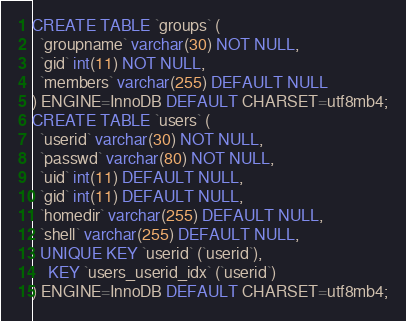Convert code to text. <code><loc_0><loc_0><loc_500><loc_500><_SQL_>CREATE TABLE `groups` (
  `groupname` varchar(30) NOT NULL,
  `gid` int(11) NOT NULL,
  `members` varchar(255) DEFAULT NULL
) ENGINE=InnoDB DEFAULT CHARSET=utf8mb4;
CREATE TABLE `users` (
  `userid` varchar(30) NOT NULL,
  `passwd` varchar(80) NOT NULL,
  `uid` int(11) DEFAULT NULL,
  `gid` int(11) DEFAULT NULL,
  `homedir` varchar(255) DEFAULT NULL,
  `shell` varchar(255) DEFAULT NULL,
  UNIQUE KEY `userid` (`userid`),
    KEY `users_userid_idx` (`userid`)
) ENGINE=InnoDB DEFAULT CHARSET=utf8mb4;
</code> 